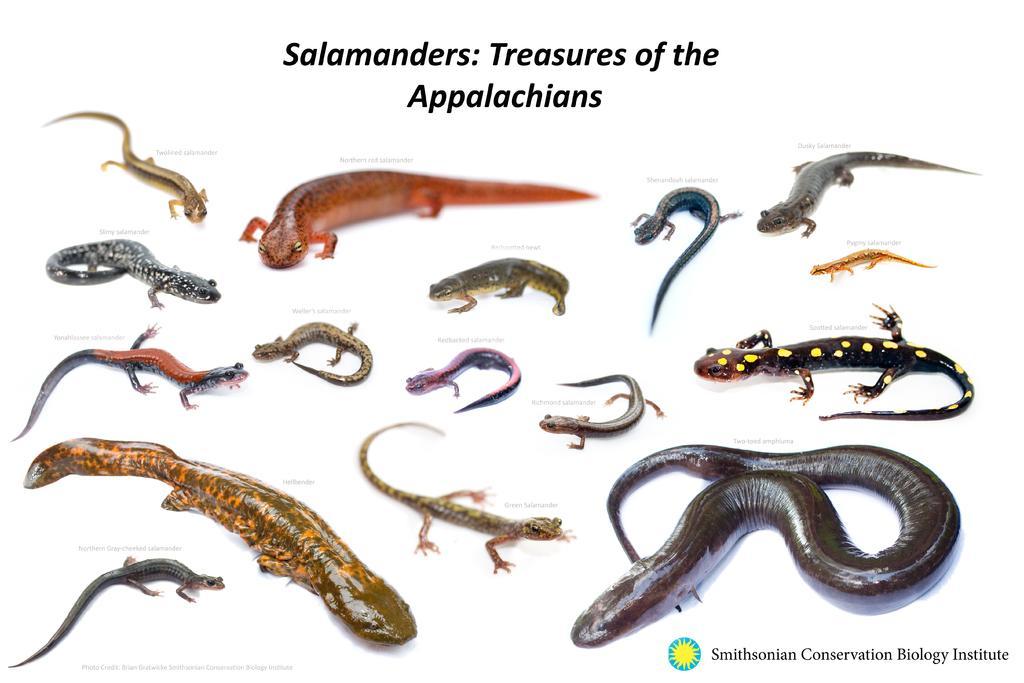In one or two sentences, can you explain what this image depicts? In this image I can see depiction of reptiles. On the top side and on the bottom right side of this image I can see something is written. 